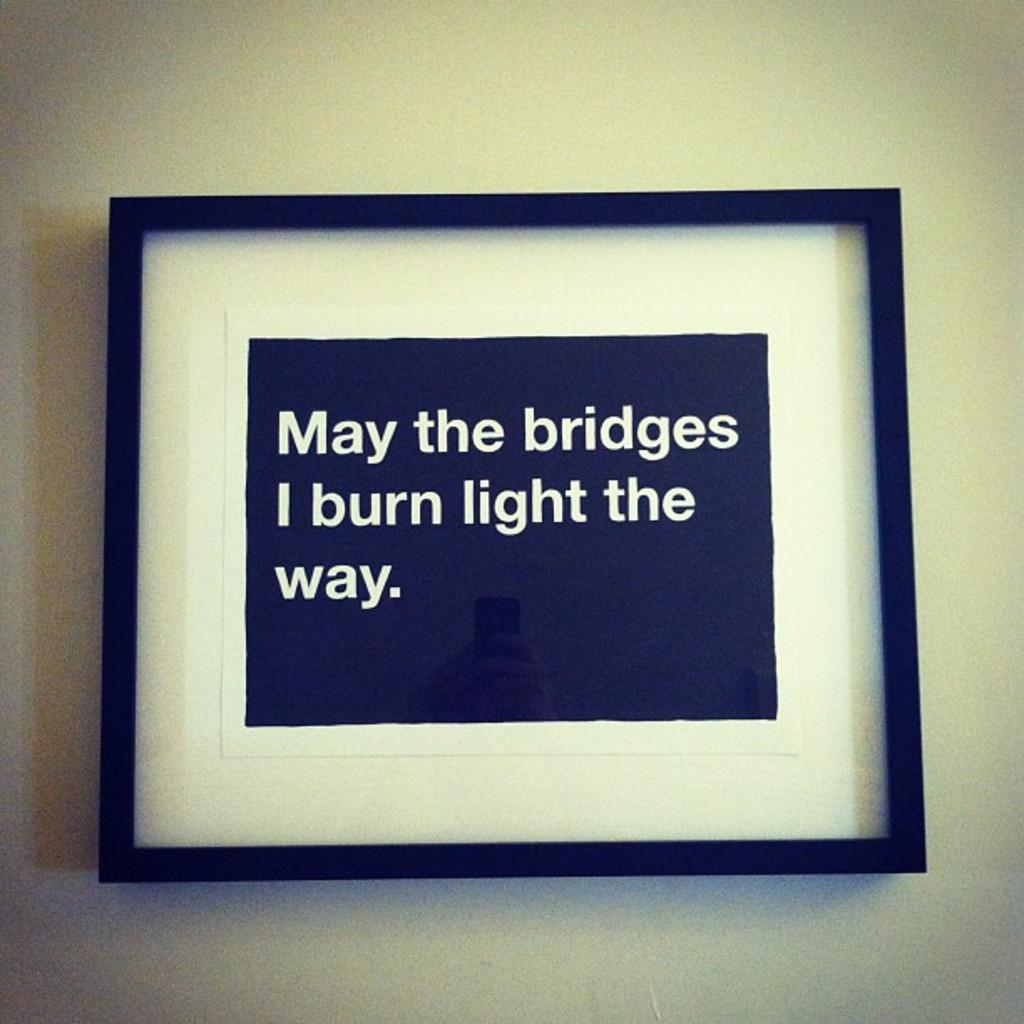Provide a one-sentence caption for the provided image. A framed sign says "May the bridges I burn light the way.". 